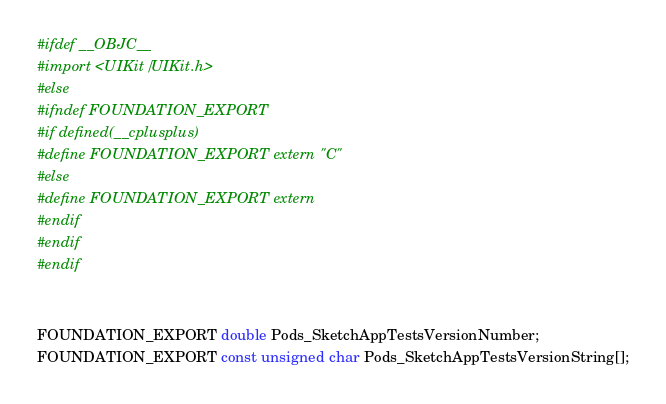Convert code to text. <code><loc_0><loc_0><loc_500><loc_500><_C_>#ifdef __OBJC__
#import <UIKit/UIKit.h>
#else
#ifndef FOUNDATION_EXPORT
#if defined(__cplusplus)
#define FOUNDATION_EXPORT extern "C"
#else
#define FOUNDATION_EXPORT extern
#endif
#endif
#endif


FOUNDATION_EXPORT double Pods_SketchAppTestsVersionNumber;
FOUNDATION_EXPORT const unsigned char Pods_SketchAppTestsVersionString[];

</code> 